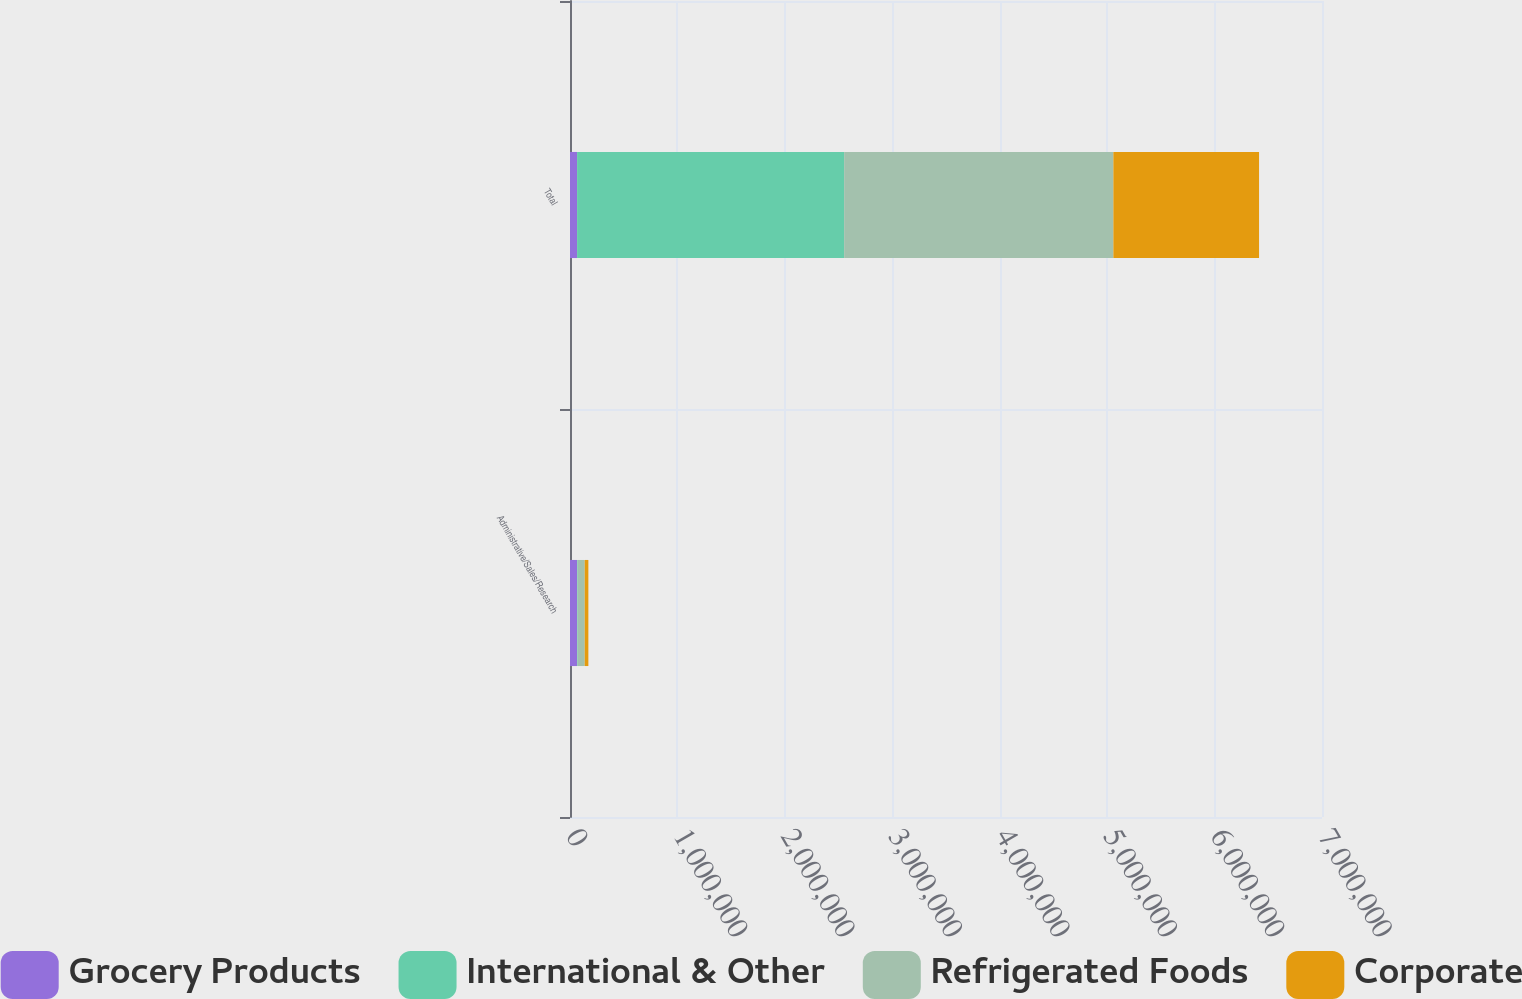Convert chart to OTSL. <chart><loc_0><loc_0><loc_500><loc_500><stacked_bar_chart><ecel><fcel>Administrative/Sales/Research<fcel>Total<nl><fcel>Grocery Products<fcel>65000<fcel>66000<nl><fcel>International & Other<fcel>6000<fcel>2.486e+06<nl><fcel>Refrigerated Foods<fcel>66000<fcel>2.506e+06<nl><fcel>Corporate<fcel>34000<fcel>1.356e+06<nl></chart> 